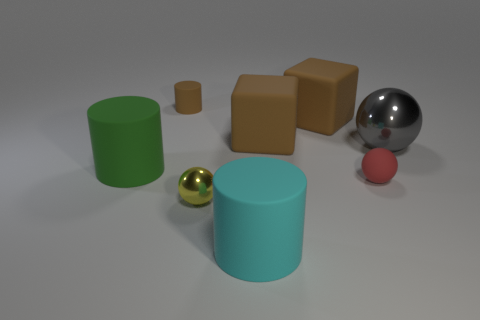There is a red object that is the same size as the yellow metallic thing; what shape is it?
Your response must be concise. Sphere. What is the big cyan thing made of?
Your response must be concise. Rubber. There is a brown thing that is on the left side of the matte cylinder right of the tiny sphere in front of the red object; what size is it?
Your answer should be very brief. Small. How many shiny objects are either large brown cylinders or gray things?
Keep it short and to the point. 1. What is the size of the yellow object?
Provide a succinct answer. Small. How many objects are metallic balls or objects that are to the right of the brown rubber cylinder?
Offer a terse response. 6. How many other objects are the same color as the tiny cylinder?
Give a very brief answer. 2. Do the red rubber ball and the rubber cylinder behind the big metal sphere have the same size?
Give a very brief answer. Yes. Do the cylinder behind the gray object and the red matte object have the same size?
Provide a short and direct response. Yes. What number of other things are the same material as the small cylinder?
Provide a short and direct response. 5. 